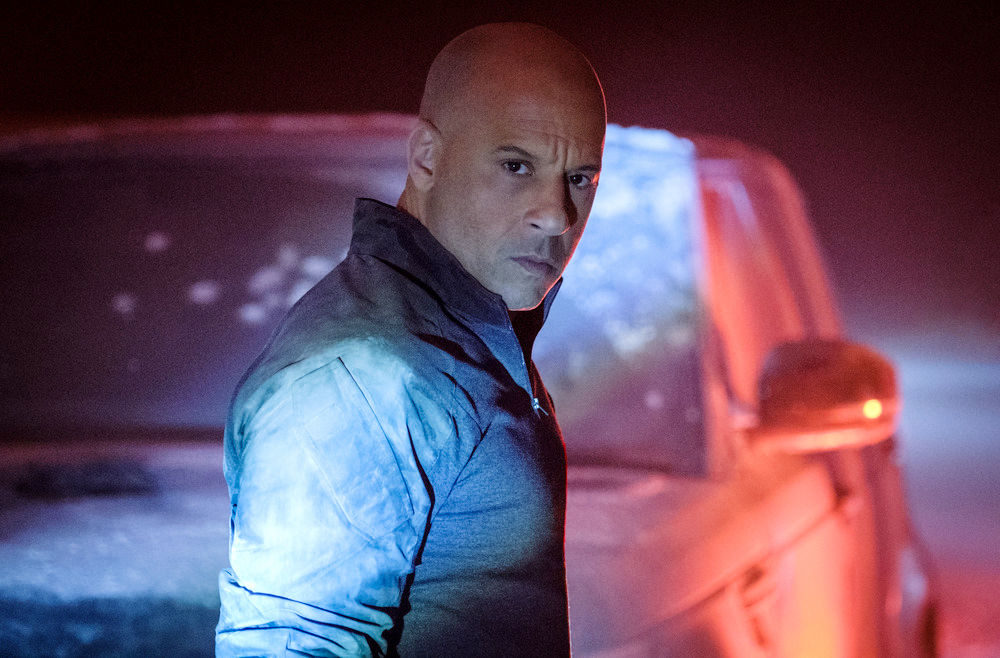Can you invent a backstory for the man in the image? The man in the image, perhaps a vigilante named Alex Stone, operates in a city troubled by corruption and crime. Once a dedicated police officer, he left the force after realizing the depth of the corruption within. Now, he uses his skills and knowledge to fight crime on his own terms. The dimly lit, foggy streets are his hunting grounds, where he meticulously plans his moves against a powerful criminal organization that once framed him for a crime he didn't commit. In this image, he stands moments before a crucial confrontation, reflecting on his journey and the challenges ahead. 